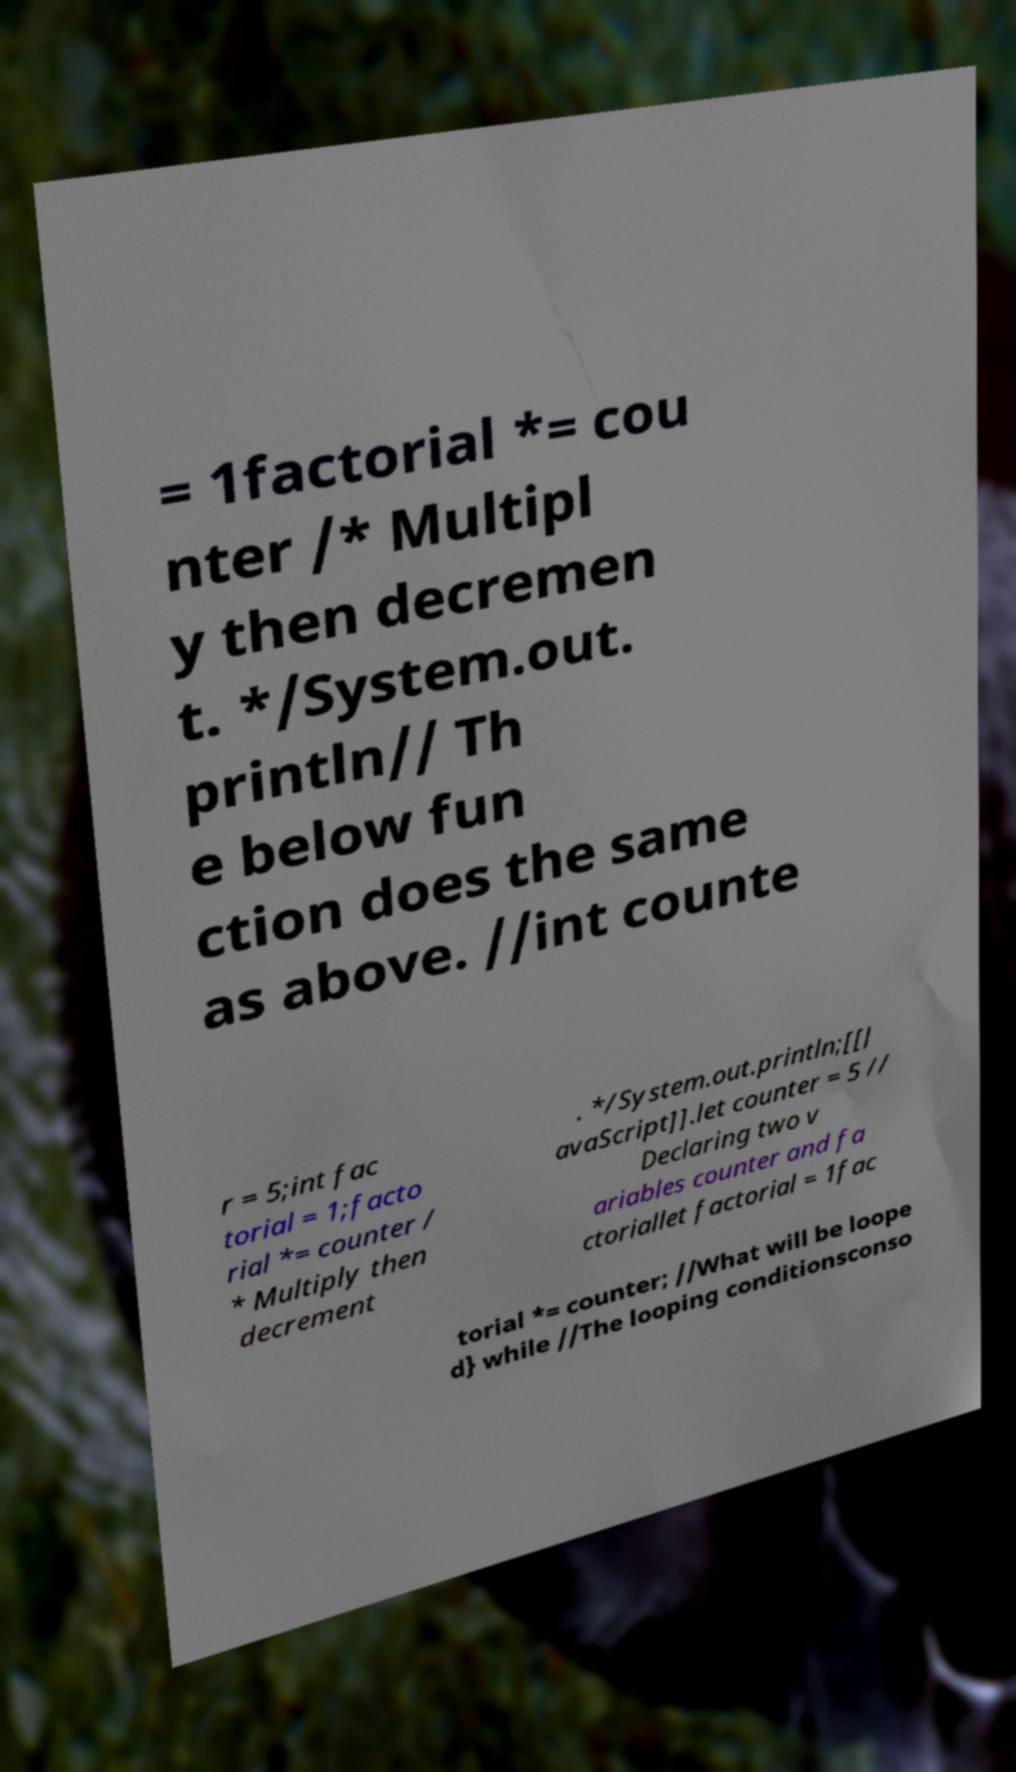What messages or text are displayed in this image? I need them in a readable, typed format. = 1factorial *= cou nter /* Multipl y then decremen t. */System.out. println// Th e below fun ction does the same as above. //int counte r = 5;int fac torial = 1;facto rial *= counter / * Multiply then decrement . */System.out.println;[[J avaScript]].let counter = 5 // Declaring two v ariables counter and fa ctoriallet factorial = 1fac torial *= counter; //What will be loope d} while //The looping conditionsconso 